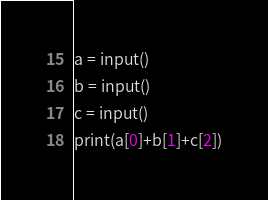<code> <loc_0><loc_0><loc_500><loc_500><_Python_>a = input()
b = input()
c = input()
print(a[0]+b[1]+c[2])</code> 